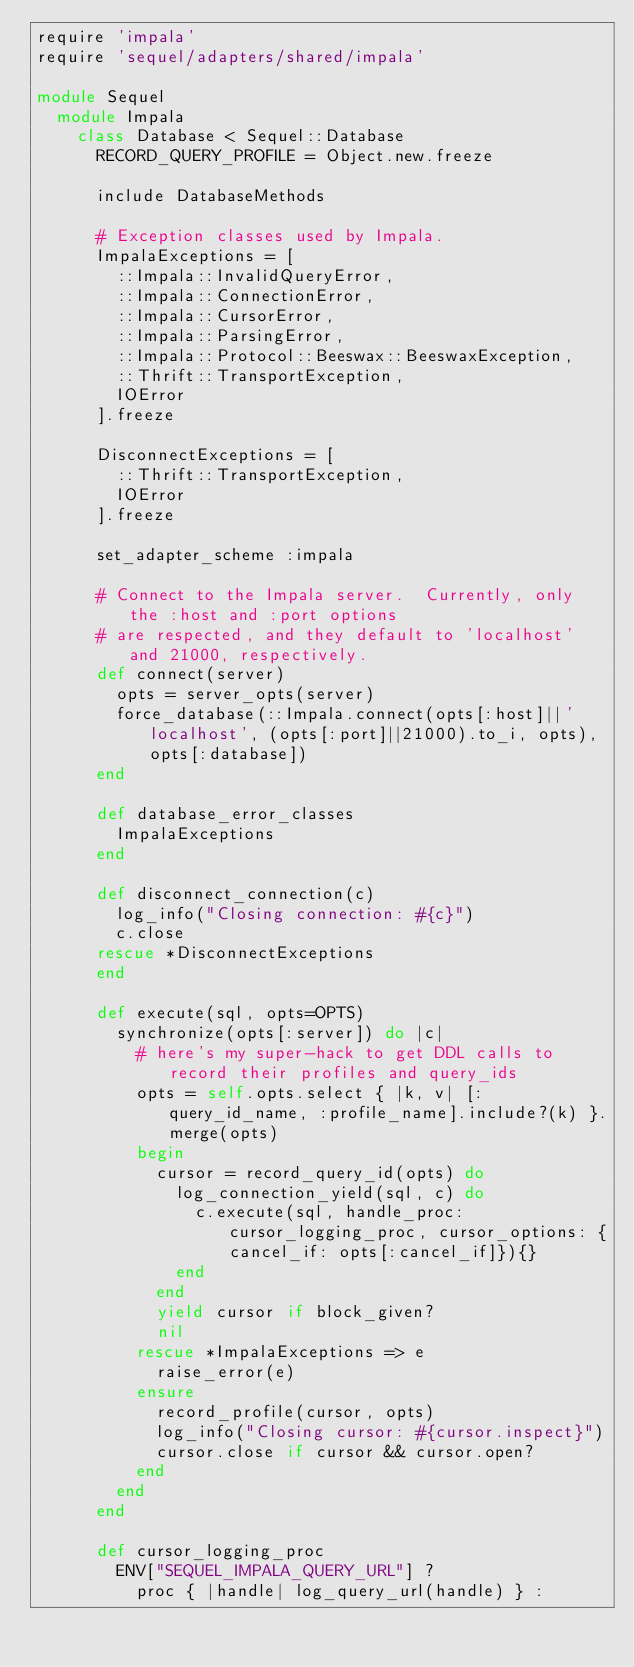Convert code to text. <code><loc_0><loc_0><loc_500><loc_500><_Ruby_>require 'impala'
require 'sequel/adapters/shared/impala'

module Sequel
  module Impala
    class Database < Sequel::Database
      RECORD_QUERY_PROFILE = Object.new.freeze

      include DatabaseMethods

      # Exception classes used by Impala.
      ImpalaExceptions = [
        ::Impala::InvalidQueryError,
        ::Impala::ConnectionError,
        ::Impala::CursorError,
        ::Impala::ParsingError,
        ::Impala::Protocol::Beeswax::BeeswaxException,
        ::Thrift::TransportException,
        IOError
      ].freeze

      DisconnectExceptions = [
        ::Thrift::TransportException,
        IOError
      ].freeze

      set_adapter_scheme :impala

      # Connect to the Impala server.  Currently, only the :host and :port options
      # are respected, and they default to 'localhost' and 21000, respectively.
      def connect(server)
        opts = server_opts(server)
        force_database(::Impala.connect(opts[:host]||'localhost', (opts[:port]||21000).to_i, opts), opts[:database])
      end

      def database_error_classes
        ImpalaExceptions
      end

      def disconnect_connection(c)
        log_info("Closing connection: #{c}")
        c.close
      rescue *DisconnectExceptions
      end

      def execute(sql, opts=OPTS)
        synchronize(opts[:server]) do |c|
          # here's my super-hack to get DDL calls to record their profiles and query_ids
          opts = self.opts.select { |k, v| [:query_id_name, :profile_name].include?(k) }.merge(opts)
          begin
            cursor = record_query_id(opts) do
              log_connection_yield(sql, c) do
                c.execute(sql, handle_proc: cursor_logging_proc, cursor_options: {cancel_if: opts[:cancel_if]}){}
              end
            end
            yield cursor if block_given?
            nil
          rescue *ImpalaExceptions => e
            raise_error(e)
          ensure
            record_profile(cursor, opts)
            log_info("Closing cursor: #{cursor.inspect}")
            cursor.close if cursor && cursor.open?
          end
        end
      end

      def cursor_logging_proc
        ENV["SEQUEL_IMPALA_QUERY_URL"] ?
          proc { |handle| log_query_url(handle) } :</code> 